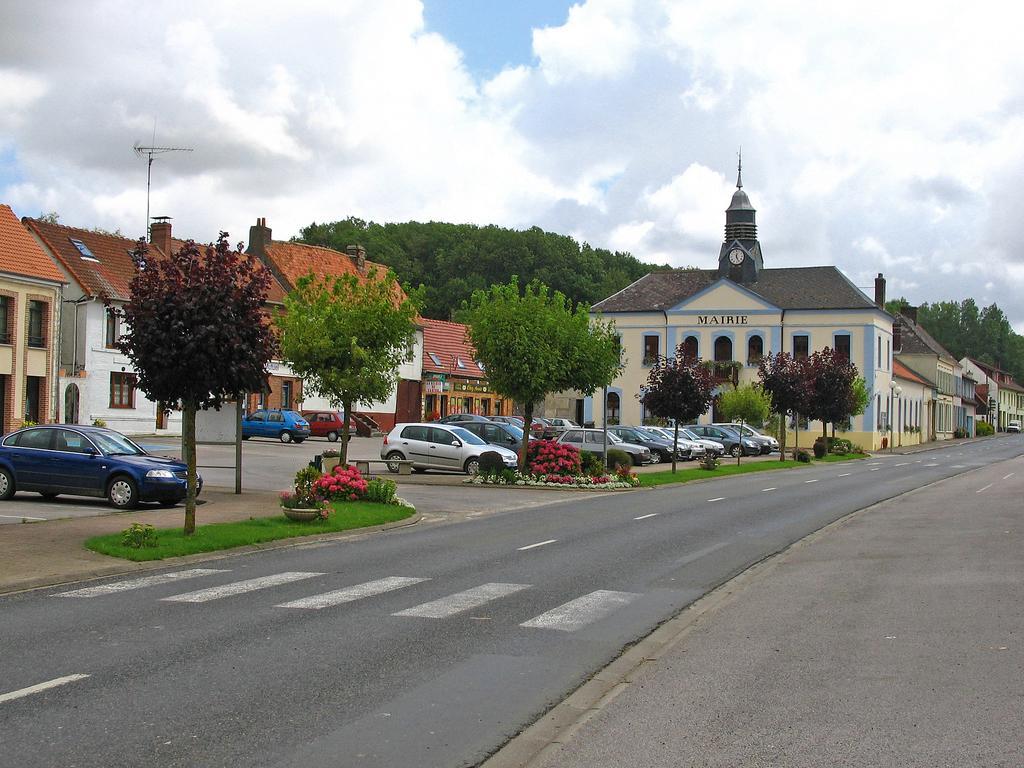How would you summarize this image in a sentence or two? In this image we can see the buildings, in front of the buildings there are cars, flowers, trees and grass. In the background, we can see the sky. 